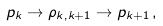<formula> <loc_0><loc_0><loc_500><loc_500>p _ { k } \rightarrow \rho _ { k , k + 1 } \rightarrow p _ { k + 1 } \, ,</formula> 